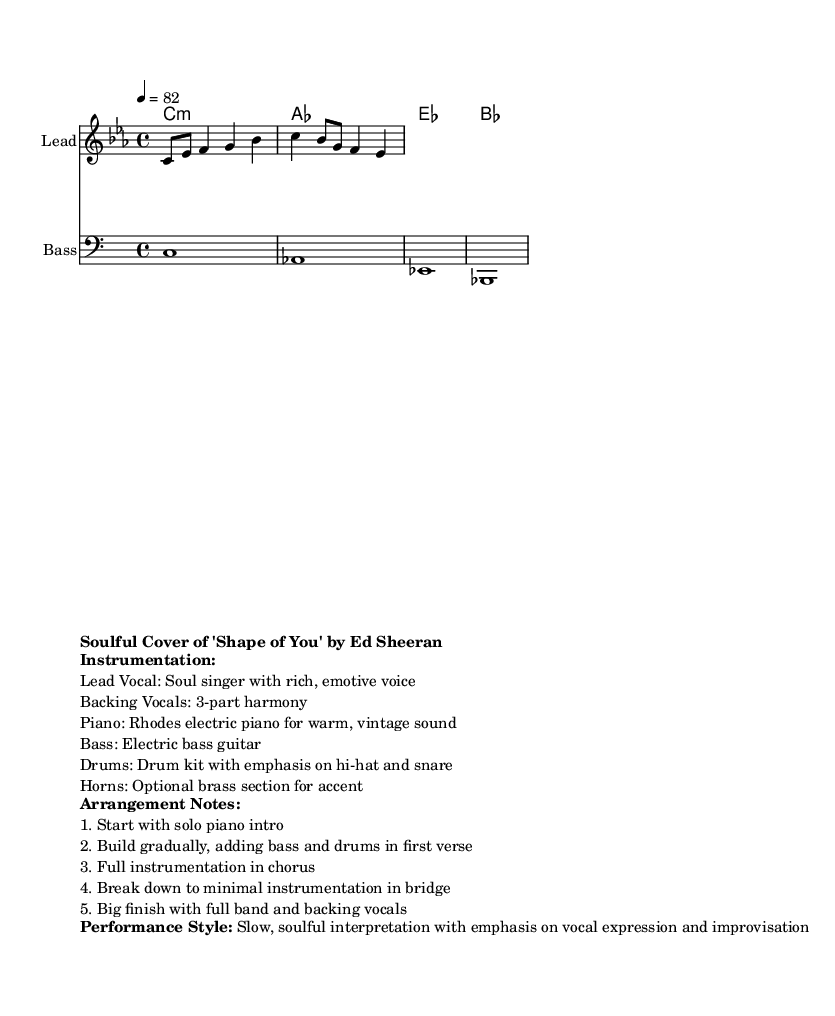What is the key signature of this music? The key signature is C minor, indicated by three flat symbols (B flat, E flat, A flat), which can be seen at the beginning of the score.
Answer: C minor What is the time signature of the piece? The time signature is 4/4, which means there are four beats in each measure. This is noted at the beginning of the score next to the key signature.
Answer: 4/4 What is the tempo marking for this music? The tempo marking is 82 beats per minute, which is written above the staff as "4 = 82."
Answer: 82 How many instruments are featured in the arrangement? The arrangement features five distinct instruments as outlined in the instrumentation section (lead vocal, backing vocals, piano, bass, and drums).
Answer: Five What is the primary performance style described for this piece? The primary performance style is described as a slow, soulful interpretation, indicating a focus on emotional depth and vocal expressiveness.
Answer: Slow, soulful How does the arrangement build from the intro to the chorus? The arrangement starts with a solo piano intro, gradually adding bass and drums during the first verse, and then reaching full instrumentation in the chorus, creating dynamic contrast and emphasis.
Answer: Gradually adding instruments 